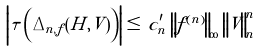Convert formula to latex. <formula><loc_0><loc_0><loc_500><loc_500>\left | \tau \left ( \Delta _ { n , f } ( H , V ) \right ) \right | \leq \, c _ { n } ^ { \prime } \, \left \| f ^ { ( n ) } \right \| _ { \infty } \, \left \| V \right \| _ { n } ^ { n }</formula> 